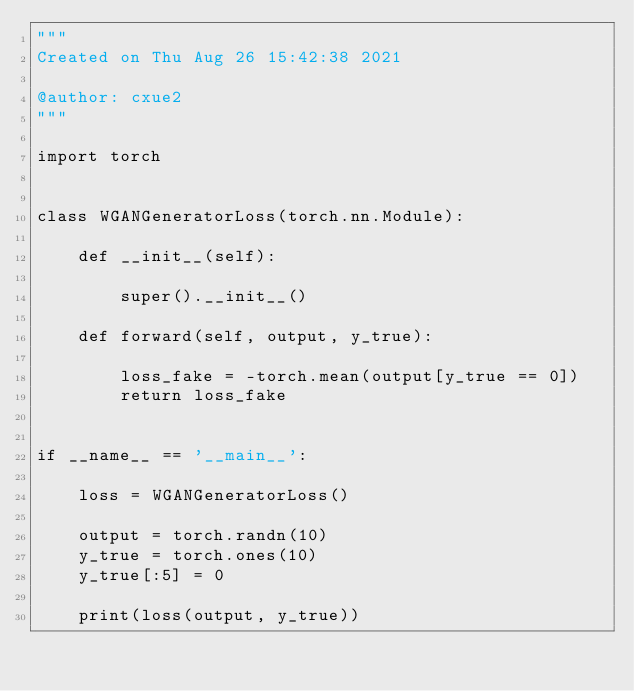Convert code to text. <code><loc_0><loc_0><loc_500><loc_500><_Python_>"""
Created on Thu Aug 26 15:42:38 2021

@author: cxue2
"""

import torch


class WGANGeneratorLoss(torch.nn.Module):

    def __init__(self):

        super().__init__()

    def forward(self, output, y_true):

        loss_fake = -torch.mean(output[y_true == 0])
        return loss_fake


if __name__ == '__main__':

    loss = WGANGeneratorLoss()

    output = torch.randn(10)
    y_true = torch.ones(10)
    y_true[:5] = 0

    print(loss(output, y_true))</code> 